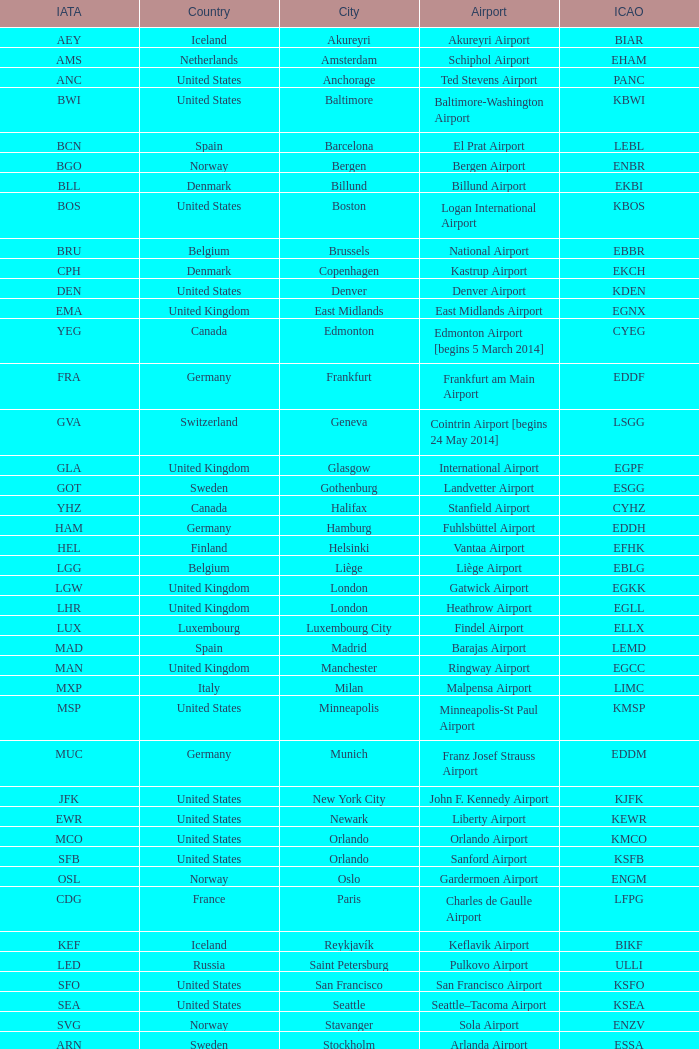What is the Airport with the ICAO fo KSEA? Seattle–Tacoma Airport. 